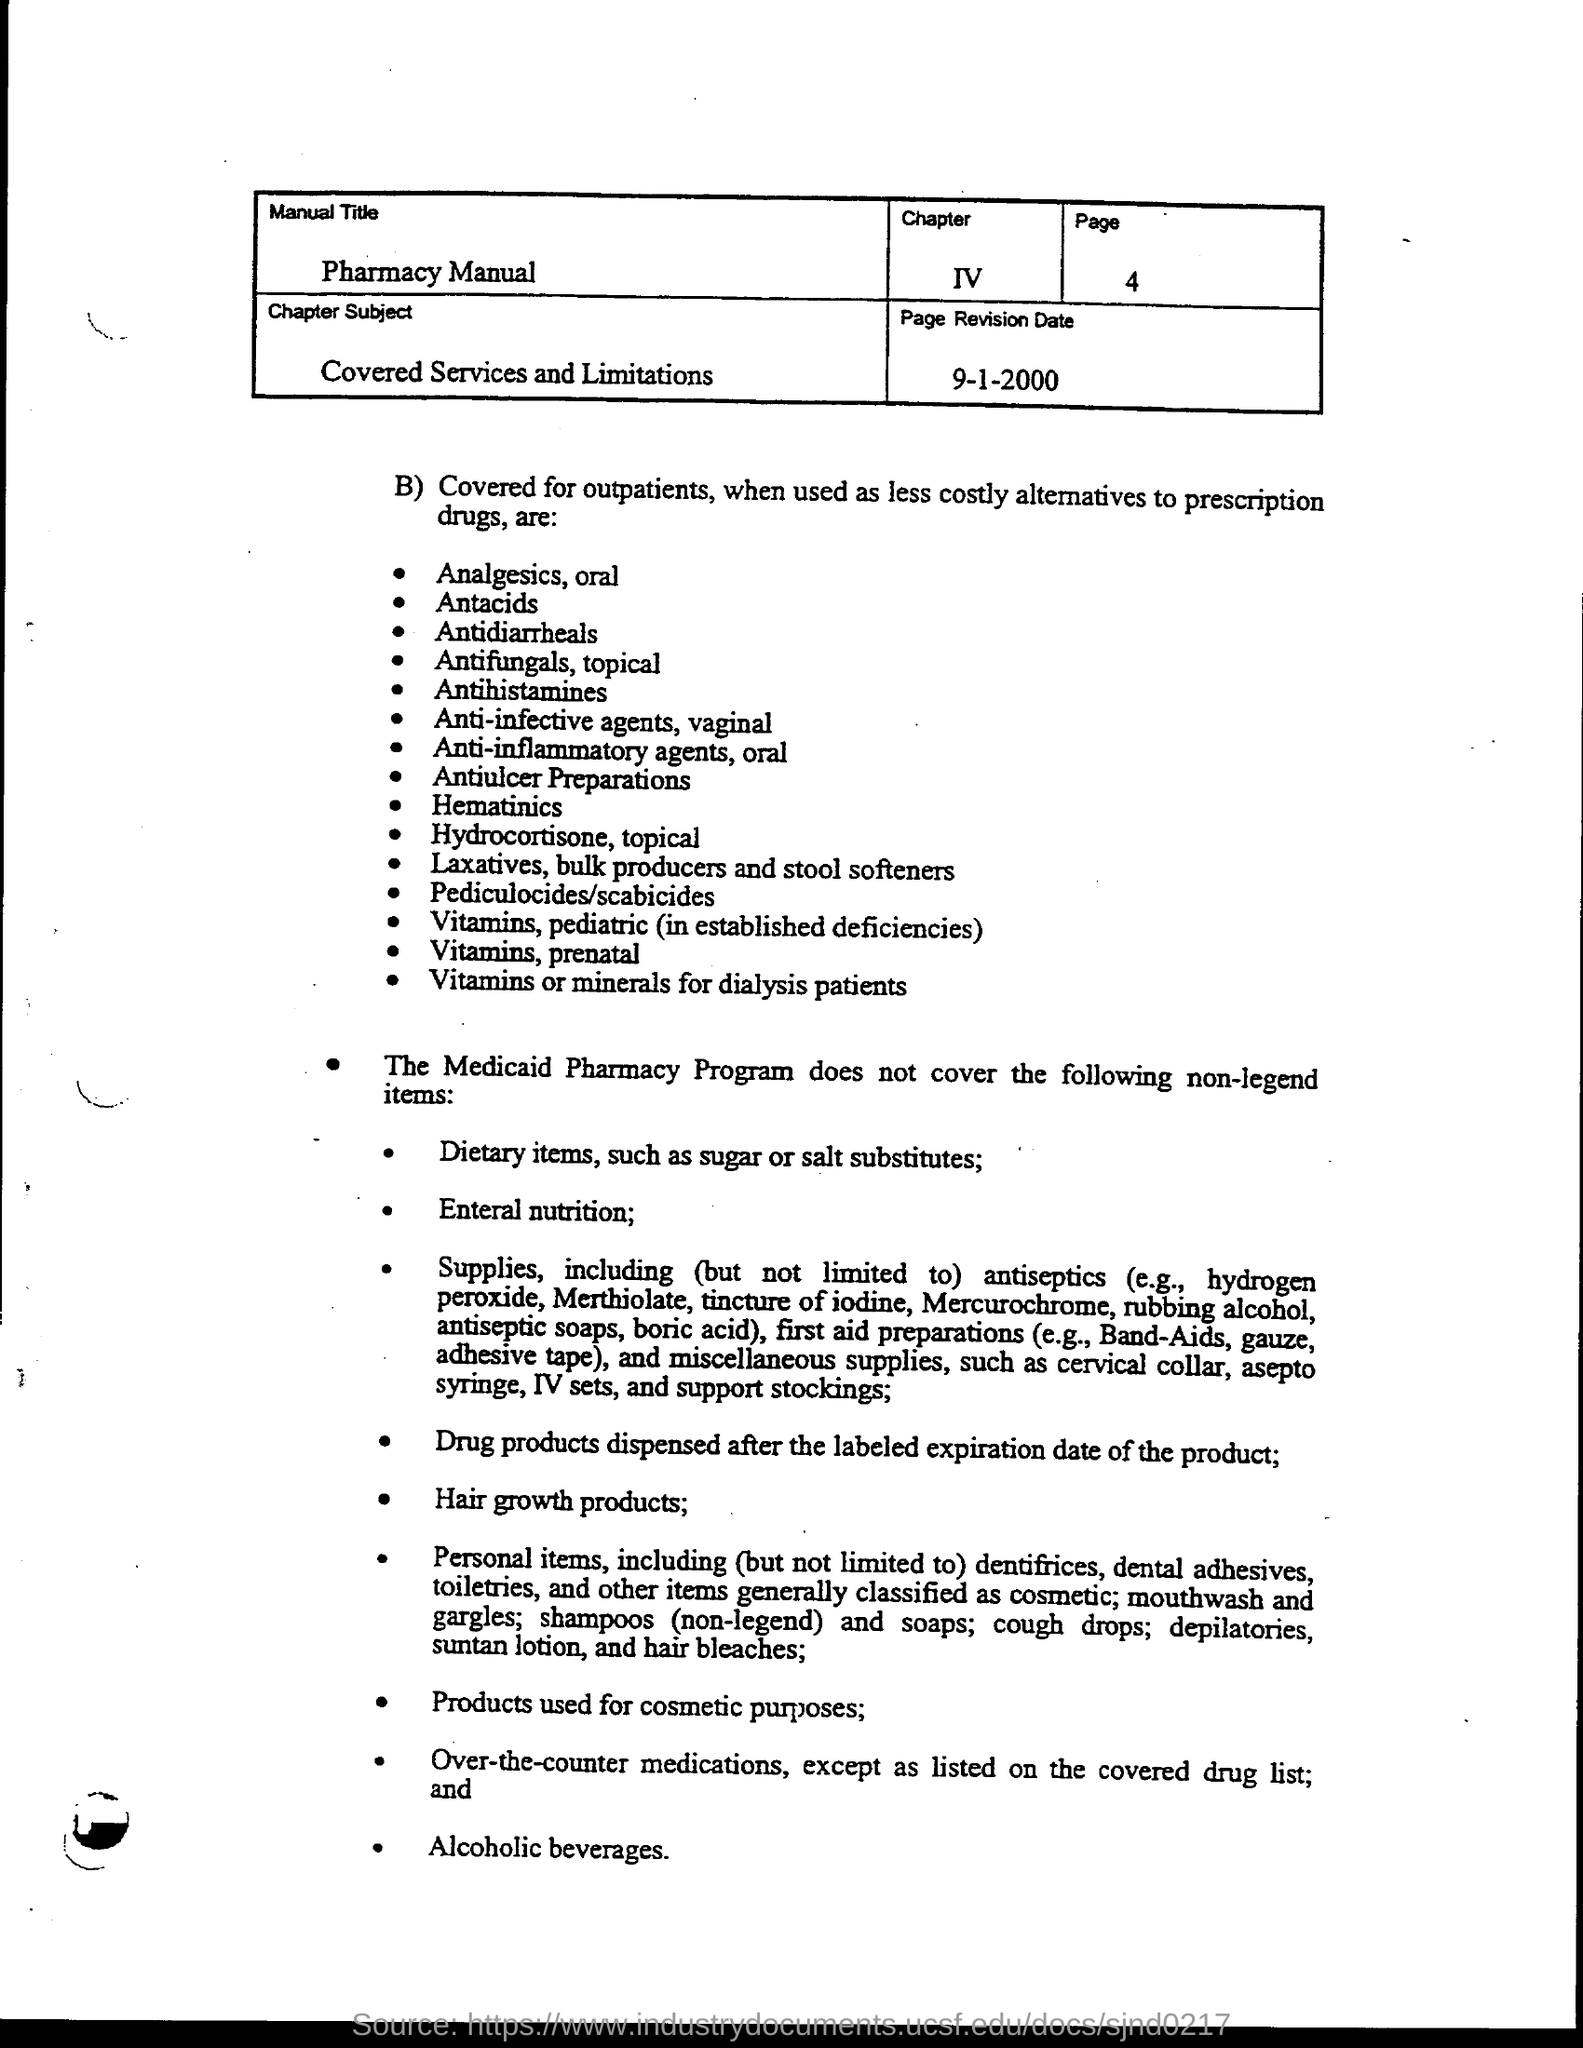What is the manual title?
Offer a terse response. Pharmacy Manual. What is the chapter number ?
Keep it short and to the point. IV. What is the page no.?
Provide a succinct answer. 4. What is the chapter subject?
Your answer should be compact. Covered services and limitations. What is the page revision date?
Your answer should be very brief. 9-1-2000. 